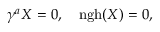<formula> <loc_0><loc_0><loc_500><loc_500>\gamma ^ { a } X = 0 , \quad n g h ( X ) = 0 ,</formula> 